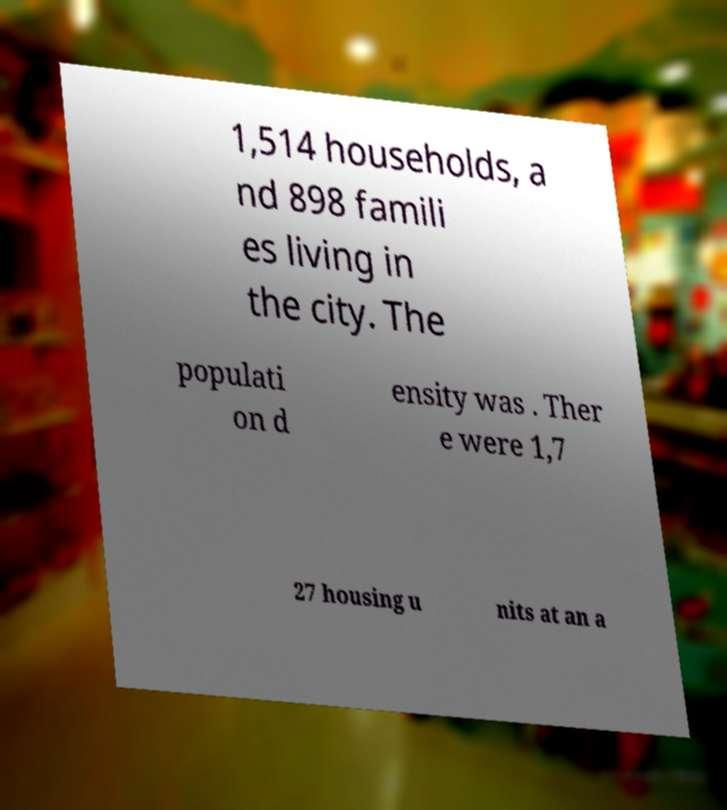What messages or text are displayed in this image? I need them in a readable, typed format. 1,514 households, a nd 898 famili es living in the city. The populati on d ensity was . Ther e were 1,7 27 housing u nits at an a 